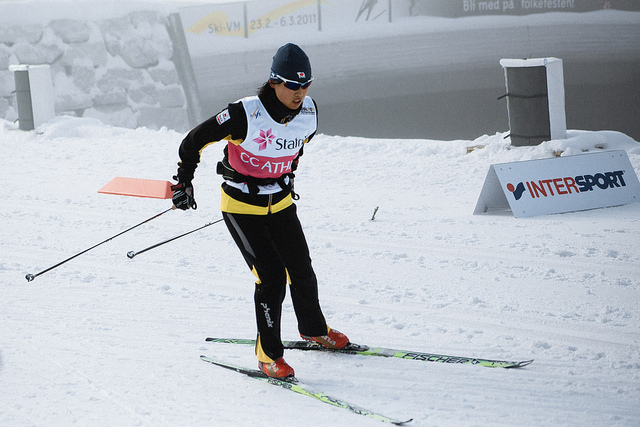Extract all visible text content from this image. INTERSPORT STAIN CC ATH 